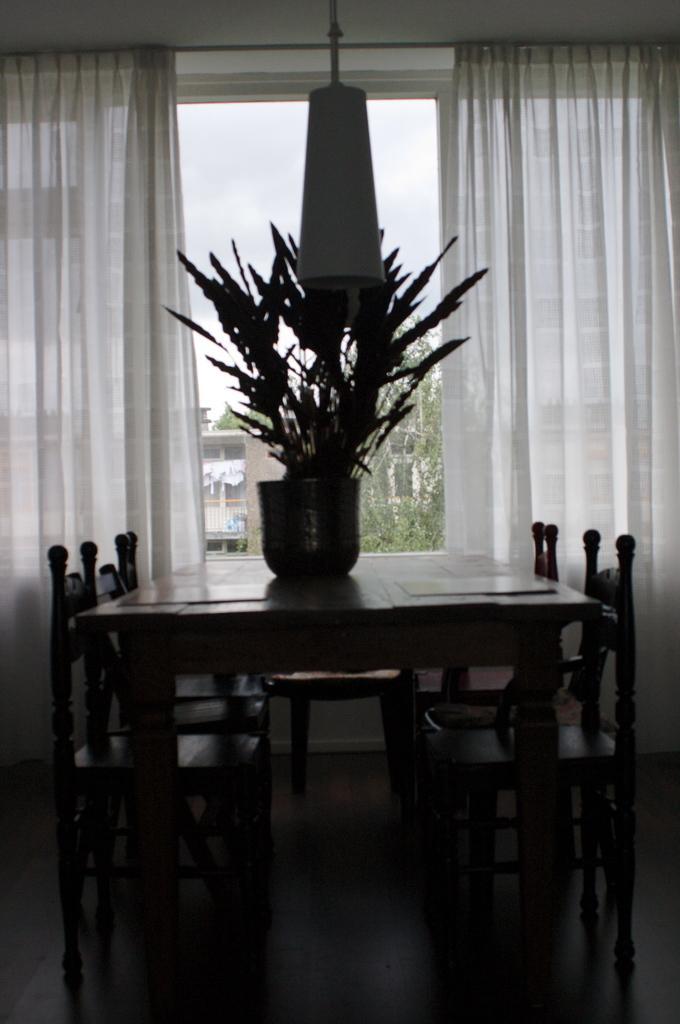Can you describe this image briefly? In this image I can see a flower and a flower vase. here I can see a table and number of chairs. In the background I can see curtains on window. 